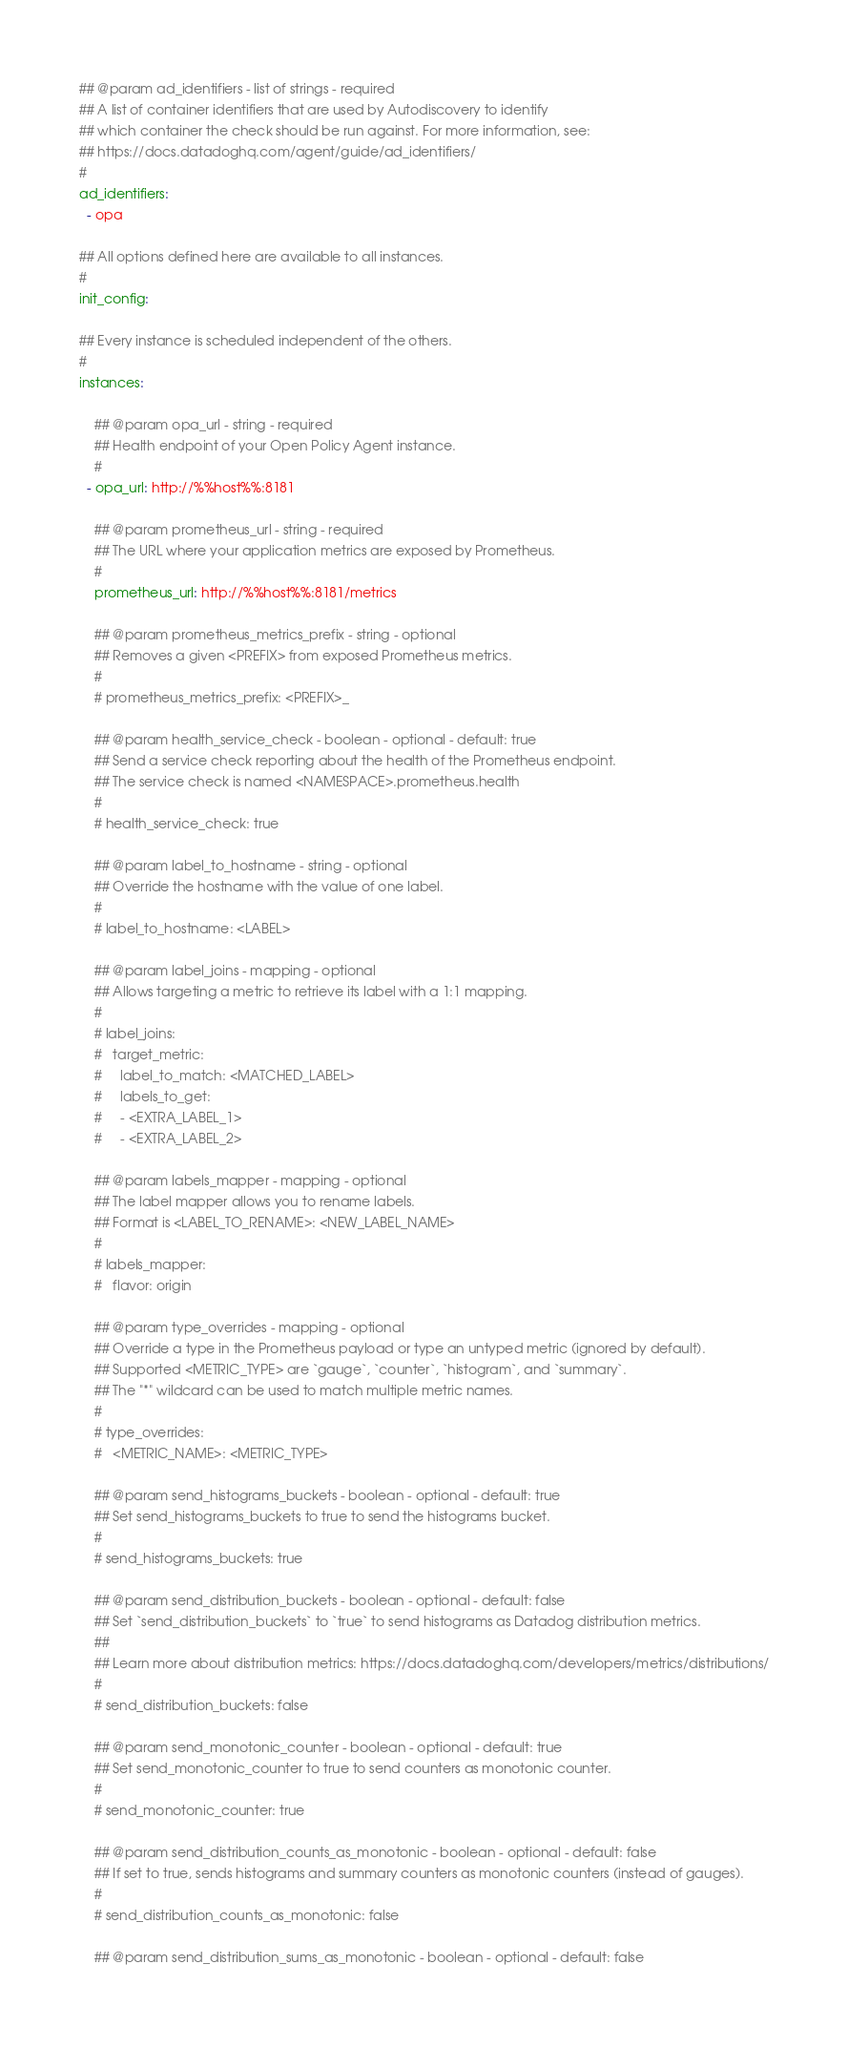<code> <loc_0><loc_0><loc_500><loc_500><_YAML_>## @param ad_identifiers - list of strings - required
## A list of container identifiers that are used by Autodiscovery to identify
## which container the check should be run against. For more information, see:
## https://docs.datadoghq.com/agent/guide/ad_identifiers/
#
ad_identifiers:
  - opa

## All options defined here are available to all instances.
#
init_config:

## Every instance is scheduled independent of the others.
#
instances:

    ## @param opa_url - string - required
    ## Health endpoint of your Open Policy Agent instance.
    #
  - opa_url: http://%%host%%:8181

    ## @param prometheus_url - string - required
    ## The URL where your application metrics are exposed by Prometheus.
    #
    prometheus_url: http://%%host%%:8181/metrics

    ## @param prometheus_metrics_prefix - string - optional
    ## Removes a given <PREFIX> from exposed Prometheus metrics.
    #
    # prometheus_metrics_prefix: <PREFIX>_

    ## @param health_service_check - boolean - optional - default: true
    ## Send a service check reporting about the health of the Prometheus endpoint.
    ## The service check is named <NAMESPACE>.prometheus.health
    #
    # health_service_check: true

    ## @param label_to_hostname - string - optional
    ## Override the hostname with the value of one label.
    #
    # label_to_hostname: <LABEL>

    ## @param label_joins - mapping - optional
    ## Allows targeting a metric to retrieve its label with a 1:1 mapping.
    #
    # label_joins:
    #   target_metric:
    #     label_to_match: <MATCHED_LABEL>
    #     labels_to_get:
    #     - <EXTRA_LABEL_1>
    #     - <EXTRA_LABEL_2>

    ## @param labels_mapper - mapping - optional
    ## The label mapper allows you to rename labels.
    ## Format is <LABEL_TO_RENAME>: <NEW_LABEL_NAME>
    #
    # labels_mapper:
    #   flavor: origin

    ## @param type_overrides - mapping - optional
    ## Override a type in the Prometheus payload or type an untyped metric (ignored by default).
    ## Supported <METRIC_TYPE> are `gauge`, `counter`, `histogram`, and `summary`.
    ## The "*" wildcard can be used to match multiple metric names.
    #
    # type_overrides:
    #   <METRIC_NAME>: <METRIC_TYPE>

    ## @param send_histograms_buckets - boolean - optional - default: true
    ## Set send_histograms_buckets to true to send the histograms bucket.
    #
    # send_histograms_buckets: true

    ## @param send_distribution_buckets - boolean - optional - default: false
    ## Set `send_distribution_buckets` to `true` to send histograms as Datadog distribution metrics.
    ##
    ## Learn more about distribution metrics: https://docs.datadoghq.com/developers/metrics/distributions/
    #
    # send_distribution_buckets: false

    ## @param send_monotonic_counter - boolean - optional - default: true
    ## Set send_monotonic_counter to true to send counters as monotonic counter.
    #
    # send_monotonic_counter: true

    ## @param send_distribution_counts_as_monotonic - boolean - optional - default: false
    ## If set to true, sends histograms and summary counters as monotonic counters (instead of gauges).
    #
    # send_distribution_counts_as_monotonic: false

    ## @param send_distribution_sums_as_monotonic - boolean - optional - default: false</code> 